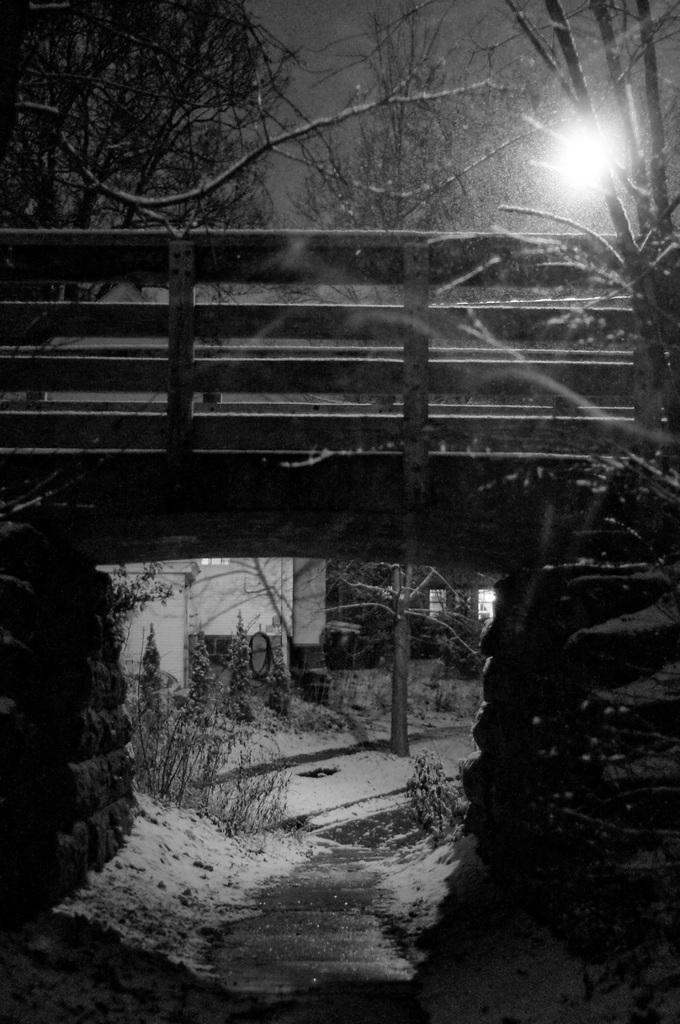What is the color scheme of the image? The image is black and white. What type of structure can be seen in the image? There is a bridge in the image. What type of vegetation is present in the image? There are plants and trees in the image. Can you describe the lighting in the image? There is light in the image. What type of building can be seen in the image? There appears to be a house in the image. What type of bottle is being used to copy the image? There is no bottle or copying process depicted in the image; it is a static representation of a scene. 